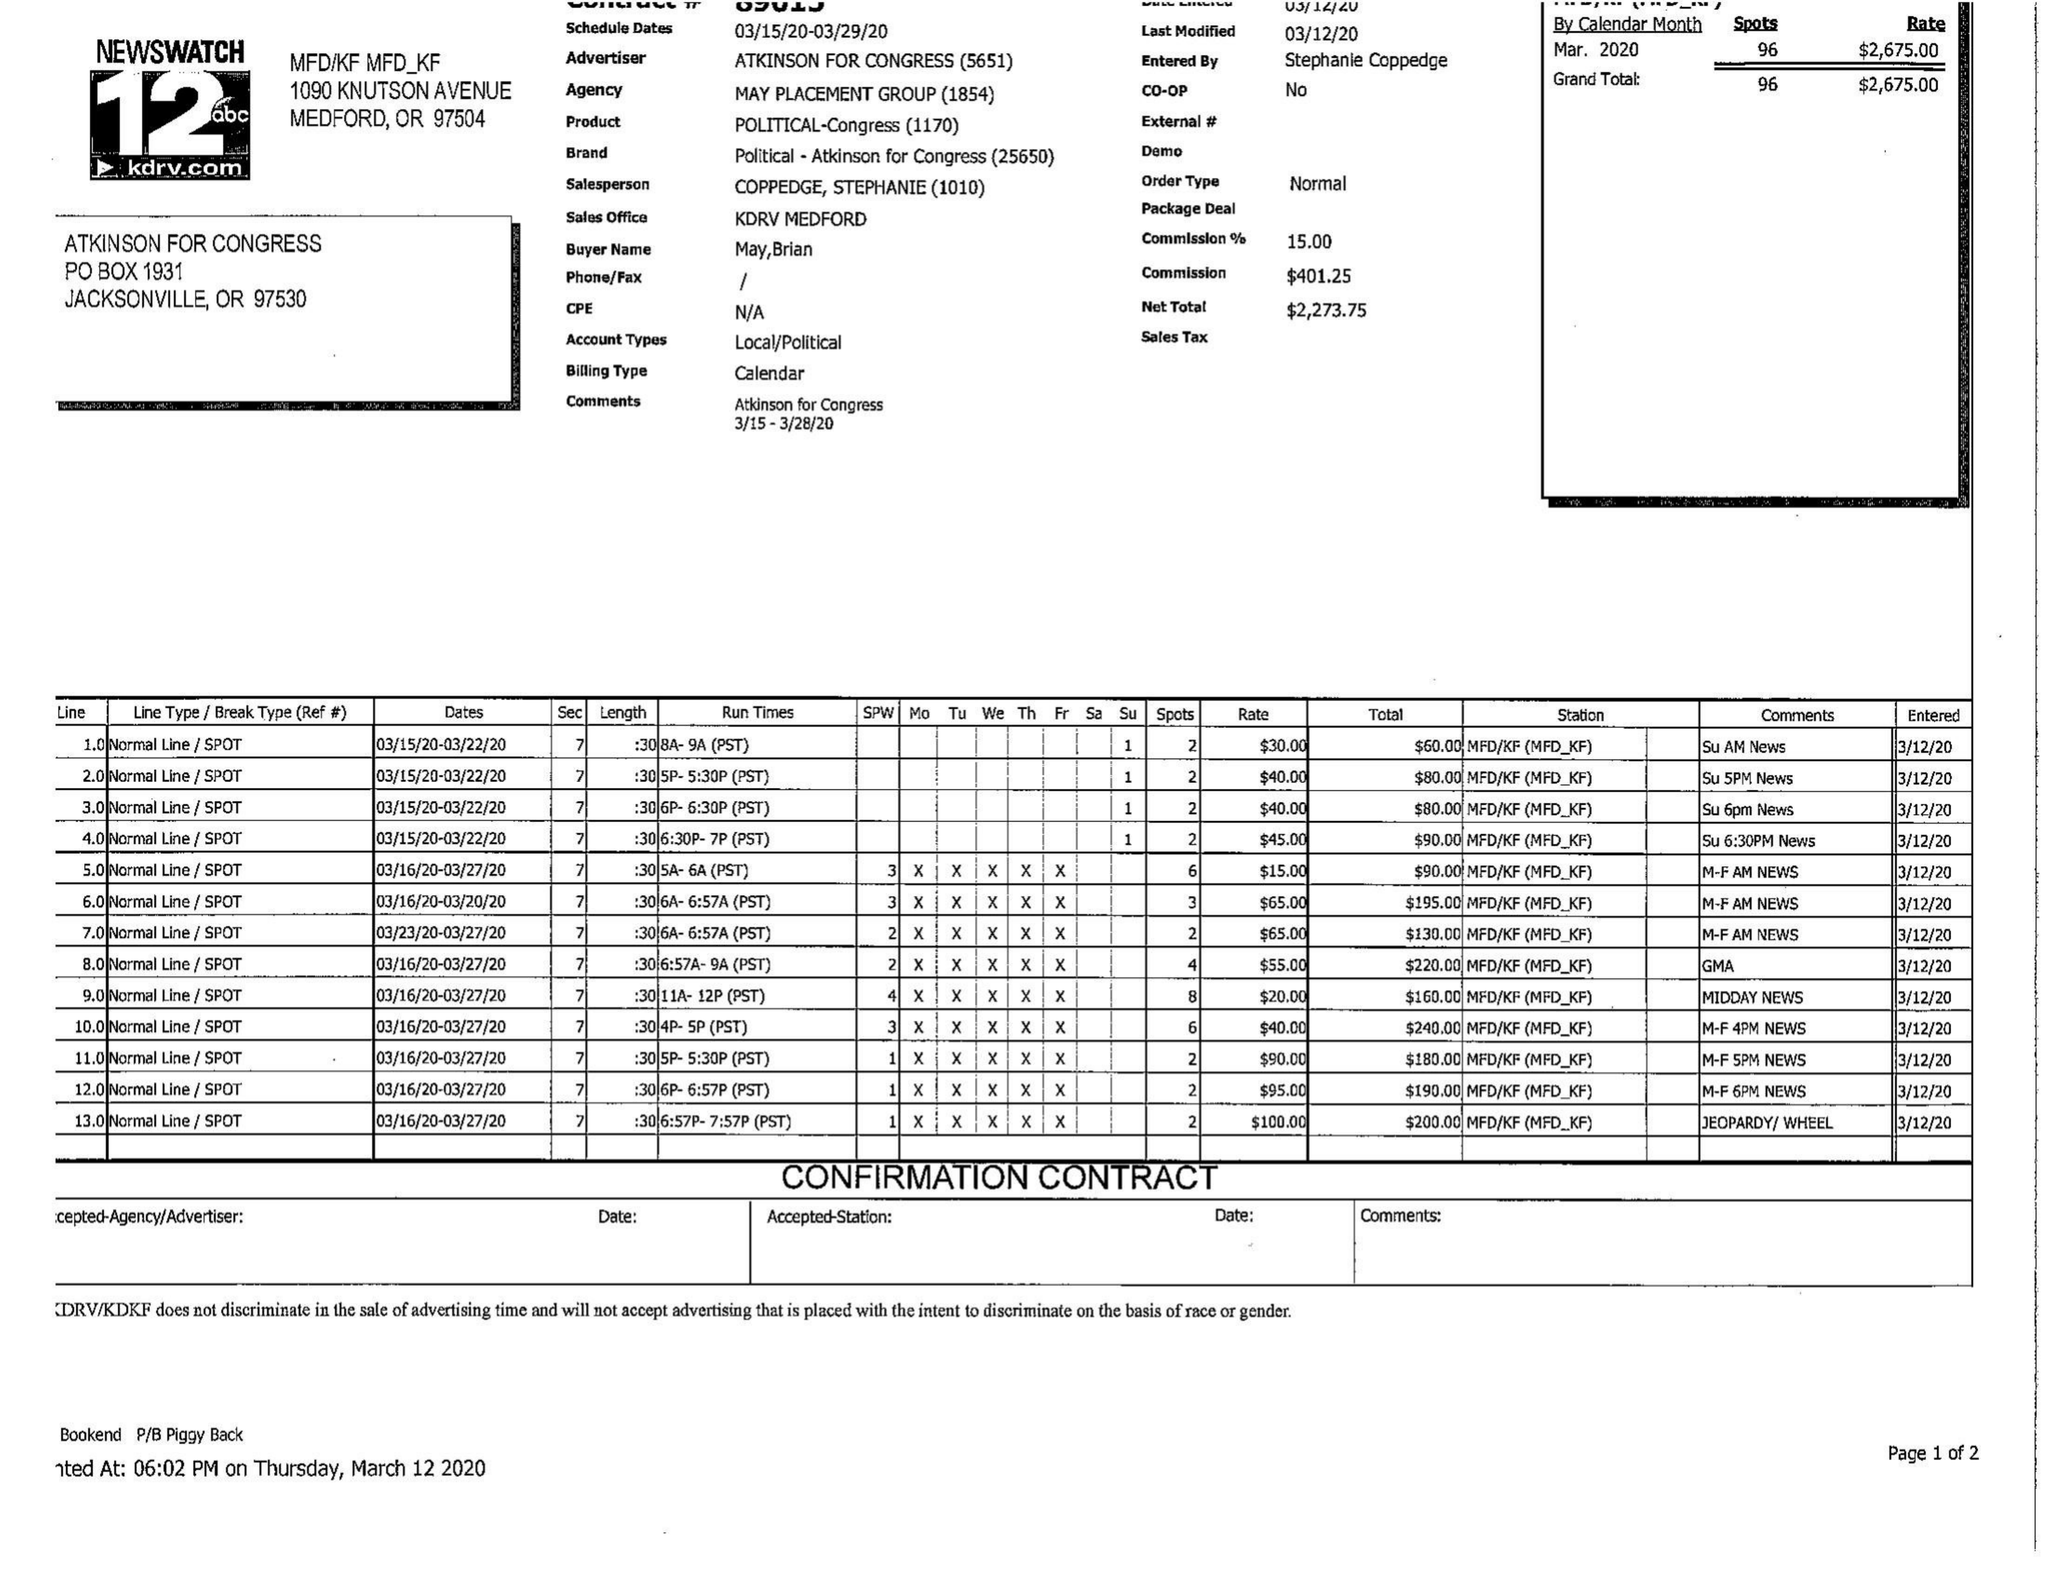What is the value for the advertiser?
Answer the question using a single word or phrase. ATKINSON FOR CONGRESS 